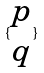<formula> <loc_0><loc_0><loc_500><loc_500>\{ \begin{matrix} p \\ q \end{matrix} \}</formula> 